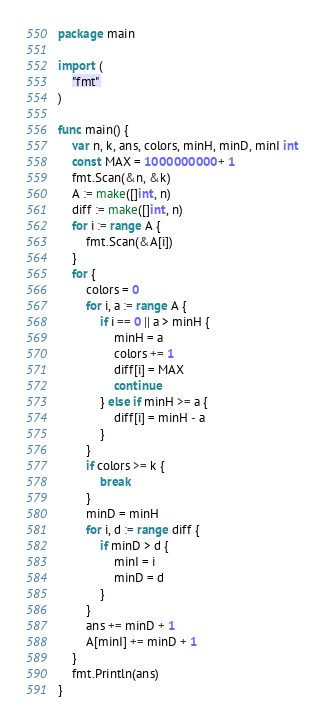<code> <loc_0><loc_0><loc_500><loc_500><_Go_>package main

import (
	"fmt"
)

func main() {
	var n, k, ans, colors, minH, minD, minI int
	const MAX = 1000000000 + 1
	fmt.Scan(&n, &k)
	A := make([]int, n)
	diff := make([]int, n)
	for i := range A {
		fmt.Scan(&A[i])
	}
	for {
		colors = 0
		for i, a := range A {
			if i == 0 || a > minH {
				minH = a
				colors += 1
				diff[i] = MAX
				continue
			} else if minH >= a {
				diff[i] = minH - a
			}
		}
		if colors >= k {
			break
		}
		minD = minH
		for i, d := range diff {
			if minD > d {
				minI = i
				minD = d
			}
		}
		ans += minD + 1
		A[minI] += minD + 1
	}
	fmt.Println(ans)
}</code> 